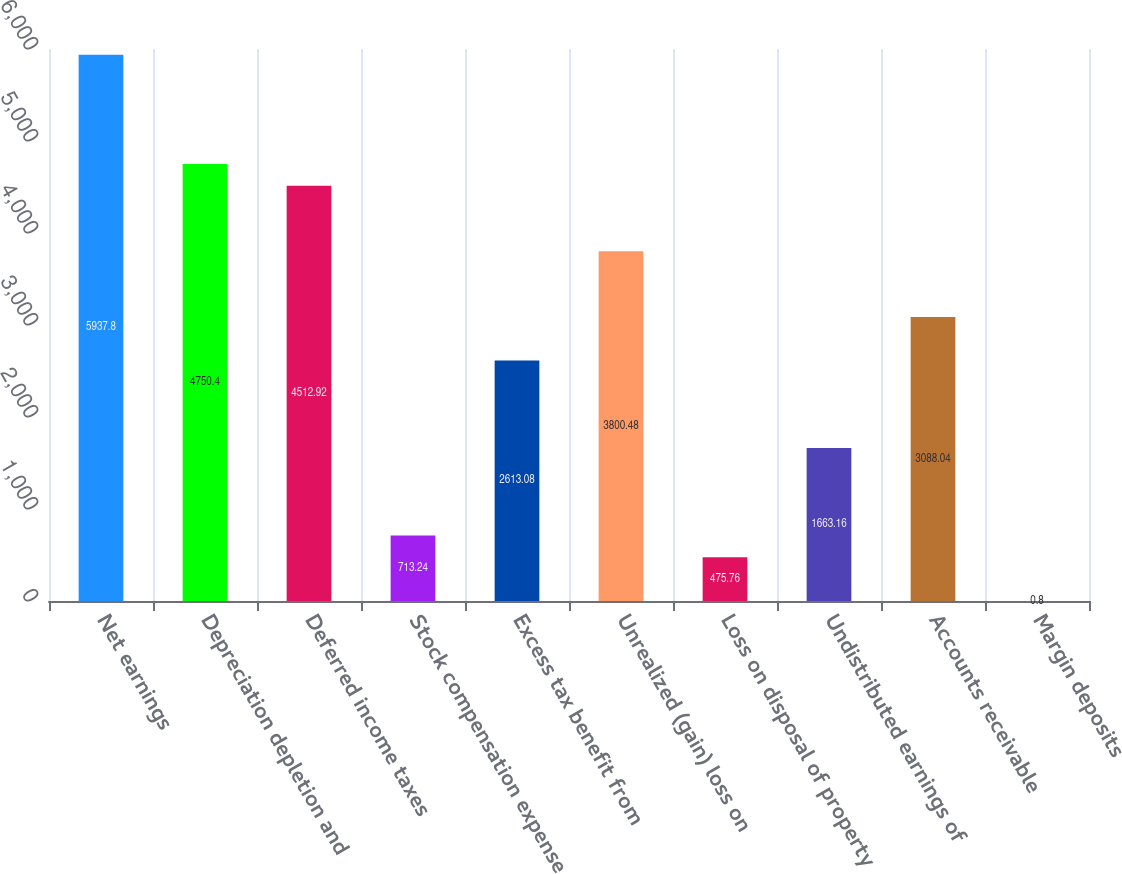<chart> <loc_0><loc_0><loc_500><loc_500><bar_chart><fcel>Net earnings<fcel>Depreciation depletion and<fcel>Deferred income taxes<fcel>Stock compensation expense<fcel>Excess tax benefit from<fcel>Unrealized (gain) loss on<fcel>Loss on disposal of property<fcel>Undistributed earnings of<fcel>Accounts receivable<fcel>Margin deposits<nl><fcel>5937.8<fcel>4750.4<fcel>4512.92<fcel>713.24<fcel>2613.08<fcel>3800.48<fcel>475.76<fcel>1663.16<fcel>3088.04<fcel>0.8<nl></chart> 